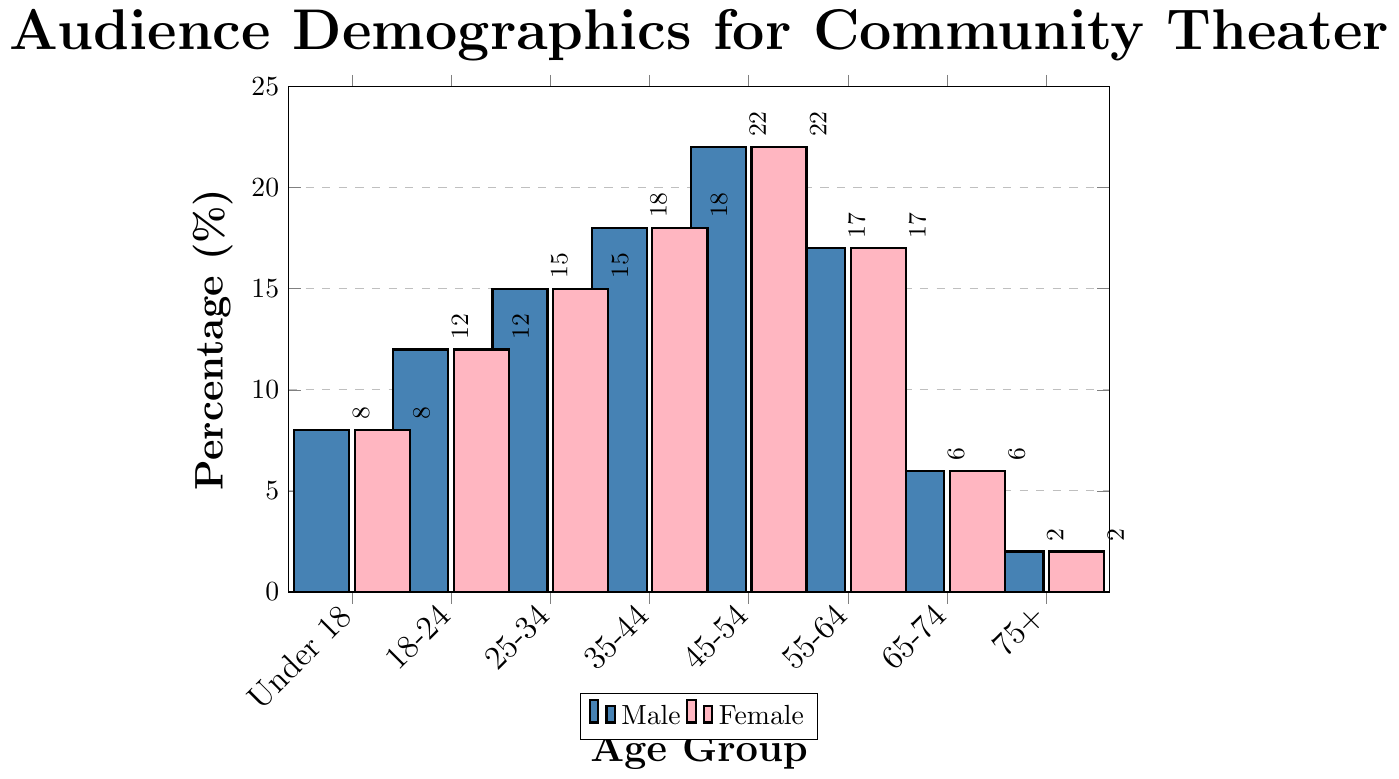Which age group has the highest percentage of the audience? The highest bar on the chart represents the age group 45-54 with a percentage of 22%.
Answer: 45-54 How many age groups have an audience percentage higher than 15%? The age groups 25-34 (15%), 35-44 (18%), 45-54 (22%), and 55-64 (17%) all have percentages higher than 15%.
Answer: 4 What is the combined audience percentage for the age groups under 18 and 65-74? The percentage for under 18 is 8% and for 65-74 is 6%. Adding these gives 8% + 6% = 14%.
Answer: 14% Which age group has the smallest audience percentage? The shortest bar on the chart represents the age group 75+ with a percentage of 2%.
Answer: 75+ How does the percentage for the age group 18-24 compare to the age group 55-64? The percentage for the age group 18-24 is 12%, while for the age group 55-64 it is 17%. 17% is higher than 12%.
Answer: 55-64 is higher What is the average audience percentage across all age groups? Sum all percentages: 8 + 12 + 15 + 18 + 22 + 17 + 6 + 2 = 100. There are 8 age groups, so the average is 100 / 8 = 12.5%.
Answer: 12.5% By how much does the audience percentage for 45-54 exceed that for 18-24? The percentage for 45-54 is 22%, and for 18-24, it is 12%. The difference is 22% - 12% = 10%.
Answer: 10% Which age groups have a combined audience percentage that equals the percentage of the age group 45-54? The age groups under 18 (8%) and 35-44 (18%) combined equal 26%, which is greater than 22%. The age groups 18-24 (12%) and 55-64 (17%) equal 29%, which is also greater. Joint percentiles must ideally match 22%. No two age groups sum to match, but under 18 + 25-34 (23%) almost combine
Answer: None What are the percentages of male and female audiences for the age group 35-44? Both male and female bars have the same height for each age group. For 35-44, the percentage is 18% for both genders.
Answer: 18% What is the difference in audience percentage between the age groups 25-34 and 65-74? The percentage for 25-34 is 15%, and for 65-74, it is 6%. The difference is 15% - 6% = 9%.
Answer: 9% 